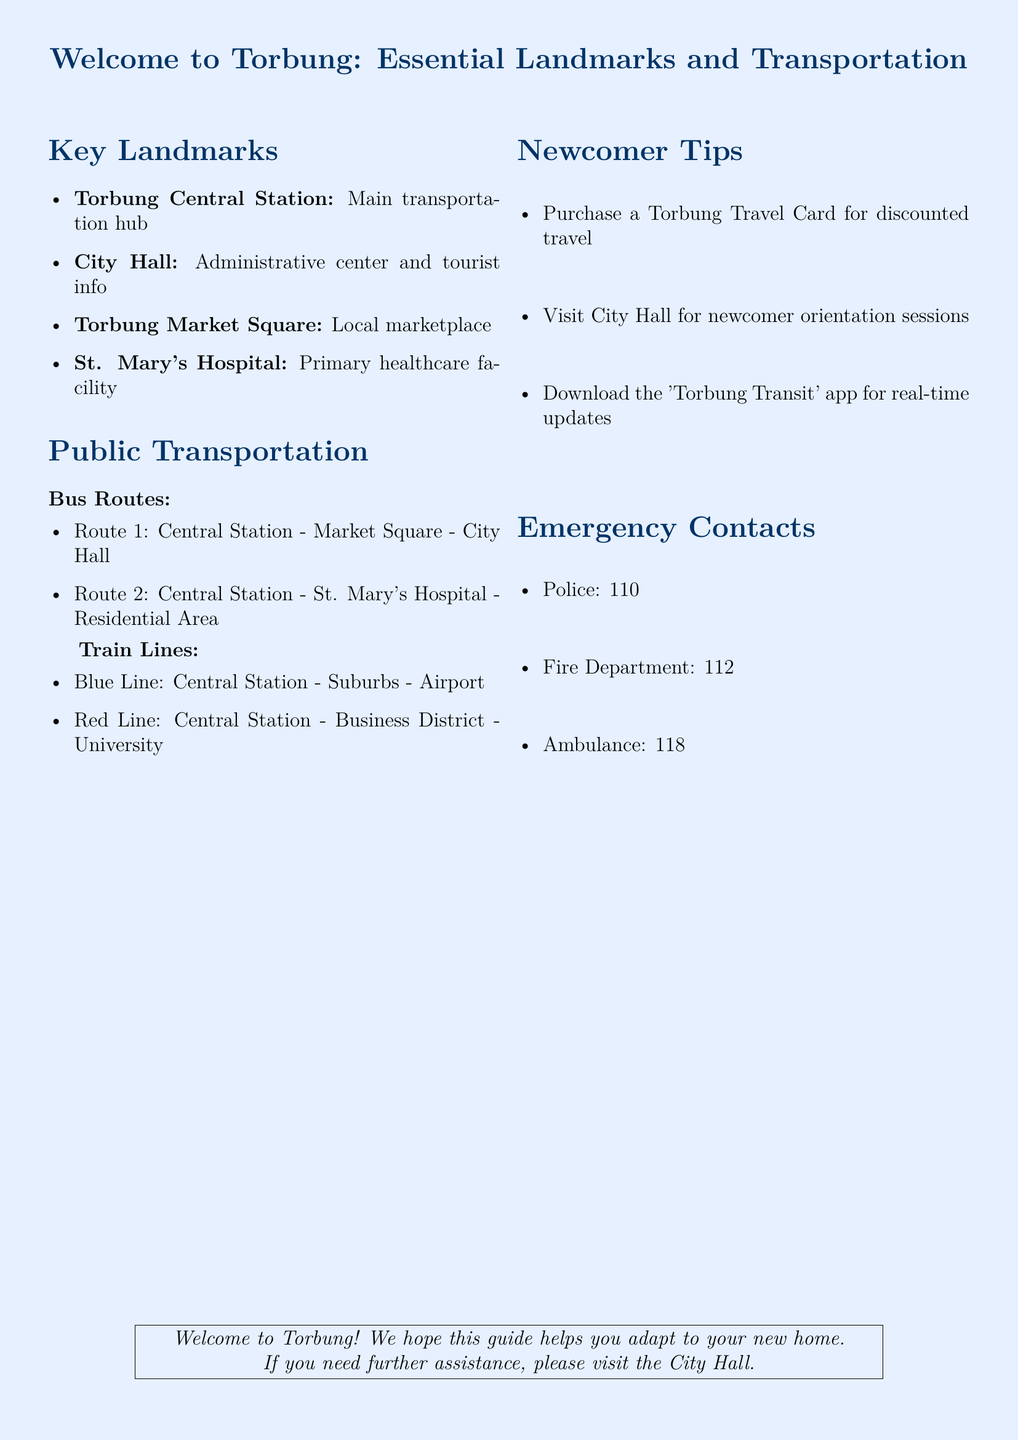What is the main transportation hub? The document states that Torbung Central Station is the main transportation hub.
Answer: Torbung Central Station What is the primary healthcare facility? According to the fax, St. Mary's Hospital is identified as the primary healthcare facility.
Answer: St. Mary's Hospital How many bus routes are mentioned? The document lists two specific bus routes under public transportation.
Answer: 2 What route connects the Central Station to the City Hall? The document specifies that Route 1 connects the Central Station to the City Hall.
Answer: Route 1 What is recommended for discounted travel? The document advises purchasing a Torbung Travel Card for discounted travel.
Answer: Torbung Travel Card Which app should newcomers download for real-time updates? Newcomers are encouraged to download the 'Torbung Transit' app for real-time updates.
Answer: Torbung Transit What are the emergency contacts for the police? The document provides the police contact number as 110.
Answer: 110 Name one landmark located near the Market Square. The Torbung Market Square is close to City Hall according to the document.
Answer: City Hall Which train line connects to the Airport? The Blue Line connects the Central Station to the Airport, as per the information in the document.
Answer: Blue Line 